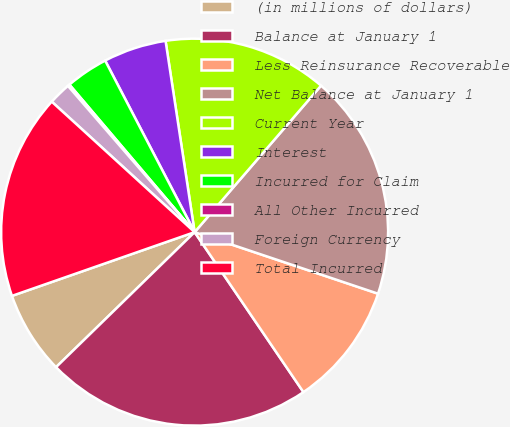<chart> <loc_0><loc_0><loc_500><loc_500><pie_chart><fcel>(in millions of dollars)<fcel>Balance at January 1<fcel>Less Reinsurance Recoverable<fcel>Net Balance at January 1<fcel>Current Year<fcel>Interest<fcel>Incurred for Claim<fcel>All Other Incurred<fcel>Foreign Currency<fcel>Total Incurred<nl><fcel>6.95%<fcel>22.21%<fcel>10.34%<fcel>18.82%<fcel>13.73%<fcel>5.25%<fcel>3.55%<fcel>0.16%<fcel>1.86%<fcel>17.12%<nl></chart> 